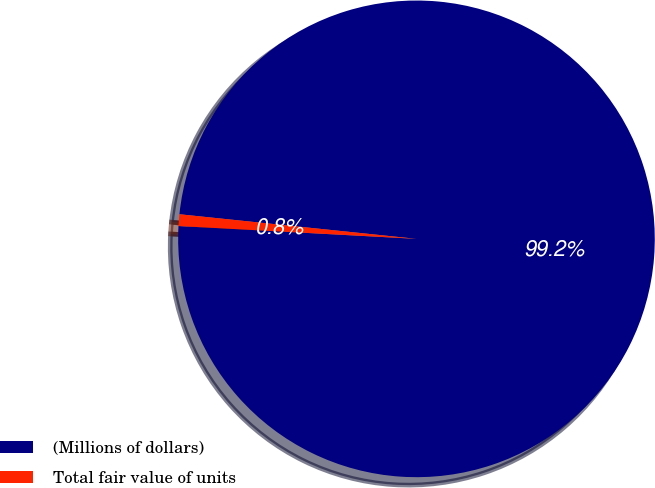Convert chart. <chart><loc_0><loc_0><loc_500><loc_500><pie_chart><fcel>(Millions of dollars)<fcel>Total fair value of units<nl><fcel>99.21%<fcel>0.79%<nl></chart> 